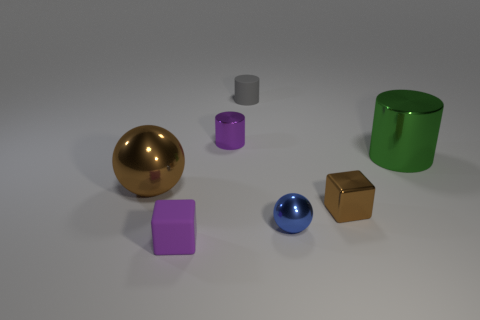What materials might these objects be made of, based on their appearance? Judging by their appearance, it can be inferred that the sphere and the cube are made of polished metal due to their high reflectivity. The cylinder and the blue sphere look like they could be made of plastic, and the purple prism appears to be opaque, possibly ceramic or matte painted metal. 